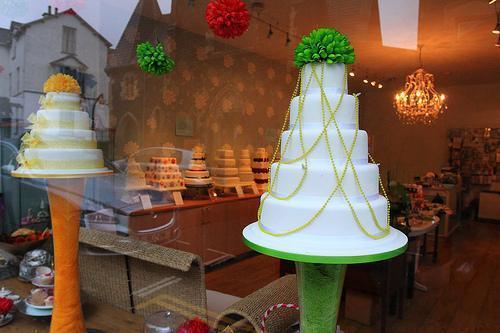How many cakes are visible?
Give a very brief answer. 8. How many layers does the leftmost cake have?
Give a very brief answer. 4. How many cakes are displayed in front?
Give a very brief answer. 2. How many tiers are on the rightmost cake?
Give a very brief answer. 5. How many cakes are on display against the wall?
Give a very brief answer. 6. 